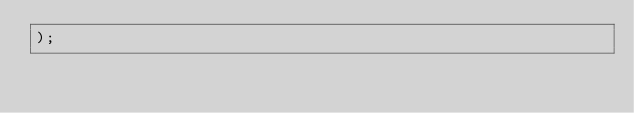<code> <loc_0><loc_0><loc_500><loc_500><_SQL_>);</code> 